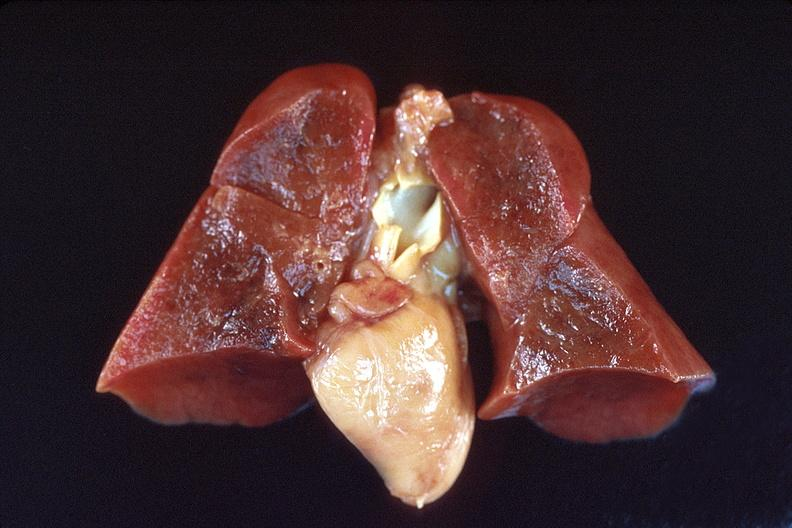does infarction secondary to shock show lungs, hyaline membrane disease?
Answer the question using a single word or phrase. No 